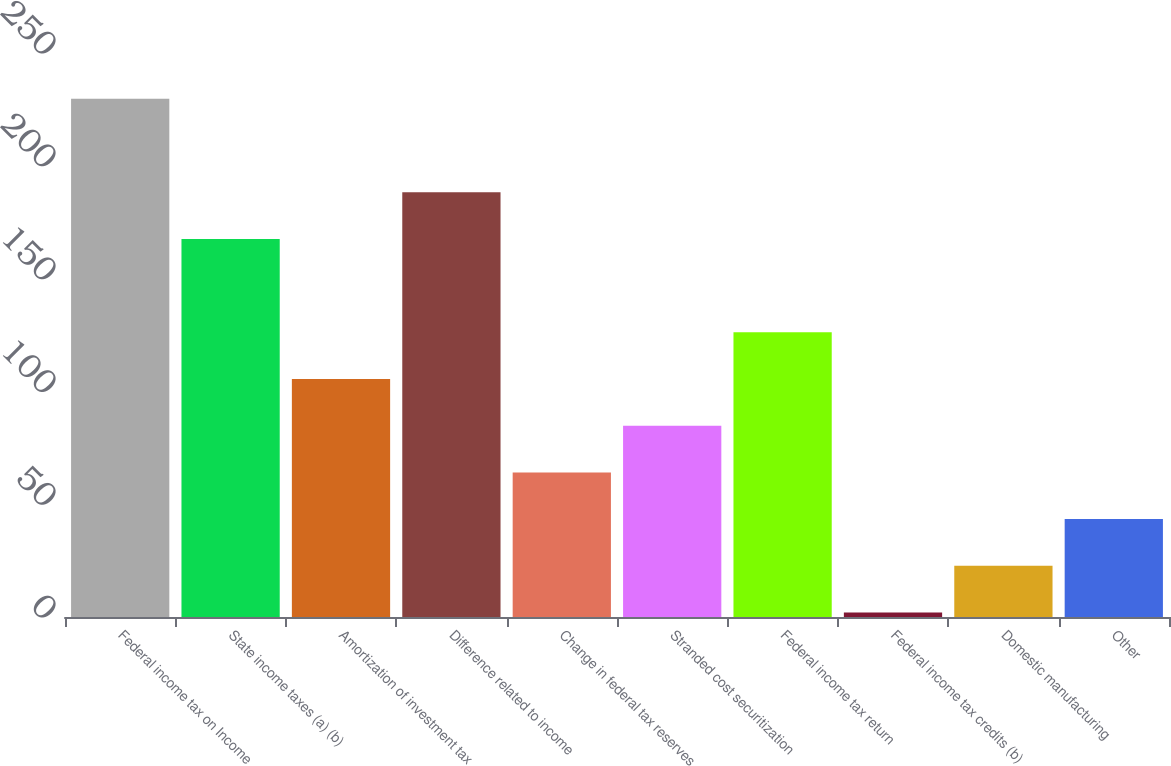Convert chart to OTSL. <chart><loc_0><loc_0><loc_500><loc_500><bar_chart><fcel>Federal income tax on Income<fcel>State income taxes (a) (b)<fcel>Amortization of investment tax<fcel>Difference related to income<fcel>Change in federal tax reserves<fcel>Stranded cost securitization<fcel>Federal income tax return<fcel>Federal income tax credits (b)<fcel>Domestic manufacturing<fcel>Other<nl><fcel>229.7<fcel>167.6<fcel>105.5<fcel>188.3<fcel>64.1<fcel>84.8<fcel>126.2<fcel>2<fcel>22.7<fcel>43.4<nl></chart> 